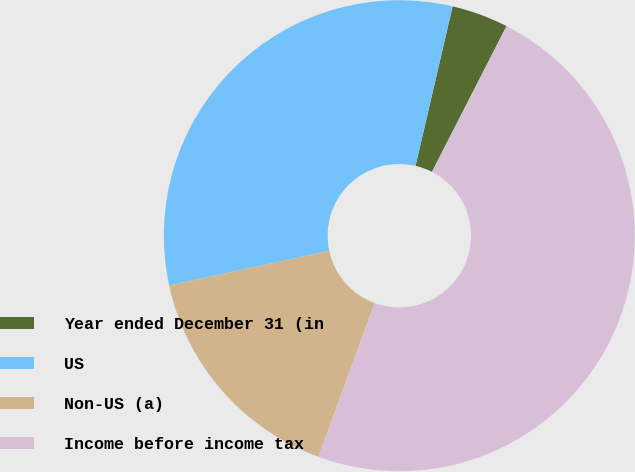<chart> <loc_0><loc_0><loc_500><loc_500><pie_chart><fcel>Year ended December 31 (in<fcel>US<fcel>Non-US (a)<fcel>Income before income tax<nl><fcel>3.89%<fcel>32.03%<fcel>16.03%<fcel>48.06%<nl></chart> 